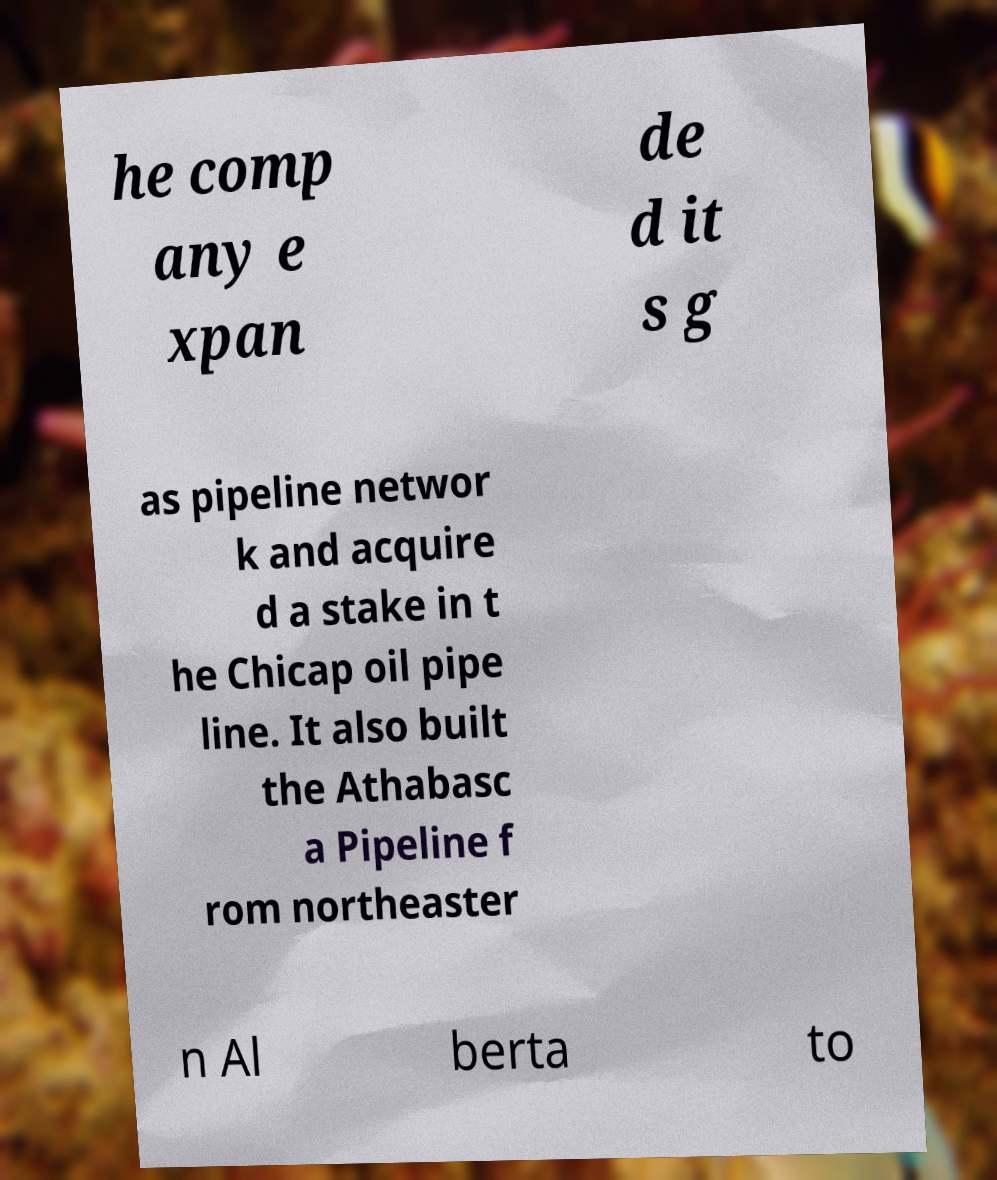Please read and relay the text visible in this image. What does it say? he comp any e xpan de d it s g as pipeline networ k and acquire d a stake in t he Chicap oil pipe line. It also built the Athabasc a Pipeline f rom northeaster n Al berta to 